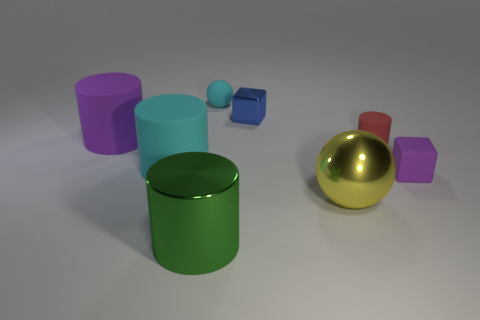Subtract all big purple cylinders. How many cylinders are left? 3 Subtract 1 spheres. How many spheres are left? 1 Subtract all cyan cylinders. How many cylinders are left? 3 Add 2 small blue balls. How many objects exist? 10 Subtract all blocks. How many objects are left? 6 Subtract all blue spheres. How many brown blocks are left? 0 Subtract 0 purple balls. How many objects are left? 8 Subtract all blue cylinders. Subtract all purple spheres. How many cylinders are left? 4 Subtract all brown metallic objects. Subtract all blue cubes. How many objects are left? 7 Add 3 large green shiny cylinders. How many large green shiny cylinders are left? 4 